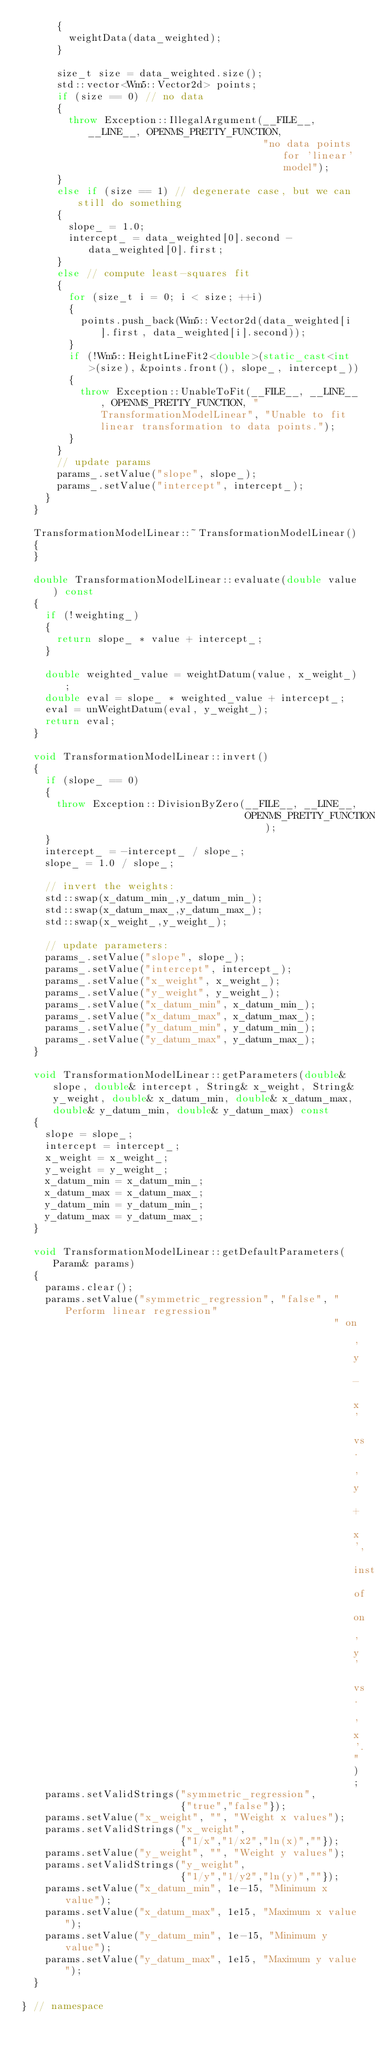<code> <loc_0><loc_0><loc_500><loc_500><_C++_>      {
        weightData(data_weighted);
      }

      size_t size = data_weighted.size();
      std::vector<Wm5::Vector2d> points;
      if (size == 0) // no data
      {
        throw Exception::IllegalArgument(__FILE__, __LINE__, OPENMS_PRETTY_FUNCTION,
                                         "no data points for 'linear' model");
      }
      else if (size == 1) // degenerate case, but we can still do something
      {               
        slope_ = 1.0;
        intercept_ = data_weighted[0].second - data_weighted[0].first;
      }
      else // compute least-squares fit
      {
        for (size_t i = 0; i < size; ++i)
        {
          points.push_back(Wm5::Vector2d(data_weighted[i].first, data_weighted[i].second));
        }
        if (!Wm5::HeightLineFit2<double>(static_cast<int>(size), &points.front(), slope_, intercept_))
        {
          throw Exception::UnableToFit(__FILE__, __LINE__, OPENMS_PRETTY_FUNCTION, "TransformationModelLinear", "Unable to fit linear transformation to data points.");
        }
      }
      // update params
      params_.setValue("slope", slope_);
      params_.setValue("intercept", intercept_);
    }
  }

  TransformationModelLinear::~TransformationModelLinear()
  {
  }

  double TransformationModelLinear::evaluate(double value) const
  {
    if (!weighting_) 
    {
      return slope_ * value + intercept_;
    }

    double weighted_value = weightDatum(value, x_weight_);
    double eval = slope_ * weighted_value + intercept_;
    eval = unWeightDatum(eval, y_weight_);
    return eval;
  }

  void TransformationModelLinear::invert()
  {
    if (slope_ == 0)
    {
      throw Exception::DivisionByZero(__FILE__, __LINE__,
                                      OPENMS_PRETTY_FUNCTION);
    }
    intercept_ = -intercept_ / slope_;
    slope_ = 1.0 / slope_;
    
    // invert the weights:
    std::swap(x_datum_min_,y_datum_min_);
    std::swap(x_datum_max_,y_datum_max_);
    std::swap(x_weight_,y_weight_);

    // update parameters:
    params_.setValue("slope", slope_);
    params_.setValue("intercept", intercept_);
    params_.setValue("x_weight", x_weight_);
    params_.setValue("y_weight", y_weight_);
    params_.setValue("x_datum_min", x_datum_min_);
    params_.setValue("x_datum_max", x_datum_max_);
    params_.setValue("y_datum_min", y_datum_min_);
    params_.setValue("y_datum_max", y_datum_max_);
  }

  void TransformationModelLinear::getParameters(double& slope, double& intercept, String& x_weight, String& y_weight, double& x_datum_min, double& x_datum_max, double& y_datum_min, double& y_datum_max) const
  {
    slope = slope_;
    intercept = intercept_;
    x_weight = x_weight_;
    y_weight = y_weight_;
    x_datum_min = x_datum_min_;
    x_datum_max = x_datum_max_;
    y_datum_min = y_datum_min_;
    y_datum_max = y_datum_max_;
  }

  void TransformationModelLinear::getDefaultParameters(Param& params)
  {
    params.clear();
    params.setValue("symmetric_regression", "false", "Perform linear regression"
                                                     " on 'y - x' vs. 'y + x', instead of on 'y' vs. 'x'.");
    params.setValidStrings("symmetric_regression",
                           {"true","false"});
    params.setValue("x_weight", "", "Weight x values");
    params.setValidStrings("x_weight",
                           {"1/x","1/x2","ln(x)",""});
    params.setValue("y_weight", "", "Weight y values");
    params.setValidStrings("y_weight",
                           {"1/y","1/y2","ln(y)",""});
    params.setValue("x_datum_min", 1e-15, "Minimum x value");
    params.setValue("x_datum_max", 1e15, "Maximum x value");
    params.setValue("y_datum_min", 1e-15, "Minimum y value");
    params.setValue("y_datum_max", 1e15, "Maximum y value");
  }

} // namespace
</code> 